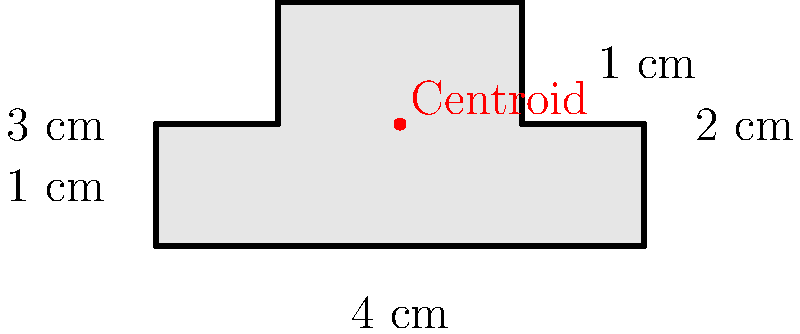Calculate the moment of inertia about the x-axis ($I_x$) for the given cross-sectional beam shape. The beam is made of a homogeneous material with uniform density. All dimensions are in centimeters. To calculate the moment of inertia about the x-axis ($I_x$), we'll use the parallel axis theorem and divide the shape into rectangles:

1. Divide the shape into three rectangles:
   R1: 4 cm × 1 cm (bottom)
   R2: 1 cm × 1 cm (left side)
   R3: 1 cm × 1 cm (right side)

2. Calculate the centroid of the entire shape:
   $\bar{y} = \frac{(4 \times 1 \times 0.5) + (1 \times 1 \times 1.5) + (1 \times 1 \times 1.5)}{4 \times 1 + 1 \times 1 + 1 \times 1} = 1$ cm

3. Calculate $I_x$ for each rectangle about its own centroidal axis:
   $I_{x1} = \frac{1}{12} \times 4 \times 1^3 = \frac{1}{3}$ cm⁴
   $I_{x2} = I_{x3} = \frac{1}{12} \times 1 \times 1^3 = \frac{1}{12}$ cm⁴

4. Apply the parallel axis theorem for each rectangle:
   $I_{x1'} = \frac{1}{3} + 4 \times 1 \times (1 - 0.5)^2 = \frac{4}{3}$ cm⁴
   $I_{x2'} = I_{x3'} = \frac{1}{12} + 1 \times 1 \times (1.5 - 1)^2 = \frac{7}{12}$ cm⁴

5. Sum the moments of inertia:
   $I_x = I_{x1'} + I_{x2'} + I_{x3'} = \frac{4}{3} + \frac{7}{12} + \frac{7}{12} = \frac{16}{6} + \frac{14}{12} = \frac{32}{12} + \frac{14}{12} = \frac{46}{12}$ cm⁴

Therefore, the moment of inertia about the x-axis is $\frac{46}{12}$ cm⁴.
Answer: $\frac{46}{12}$ cm⁴ 